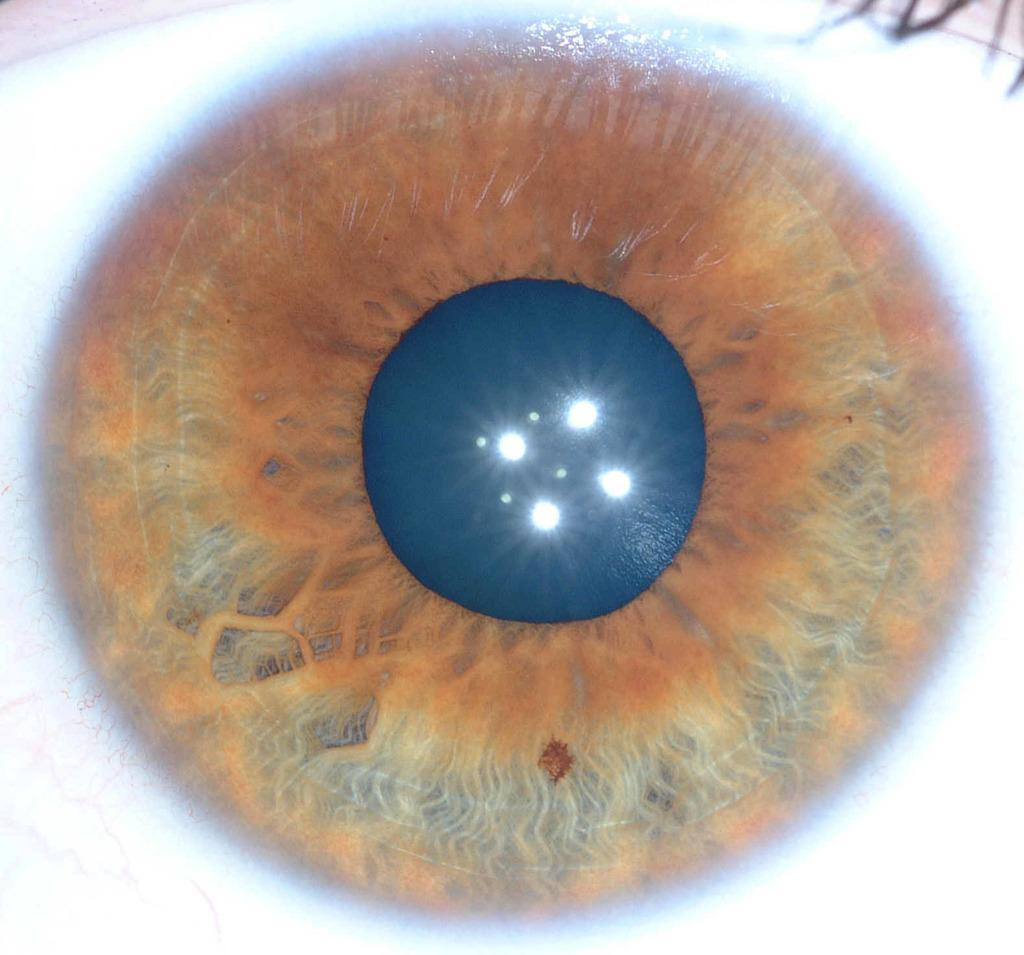What is the main subject of the image? The main subject of the image is an eye. What type of birthday celebration is depicted in the image? There is no birthday celebration depicted in the image; it only features an eye. What type of smell can be detected in the image? There is no smell present in the image, as it is a visual representation of an eye. 